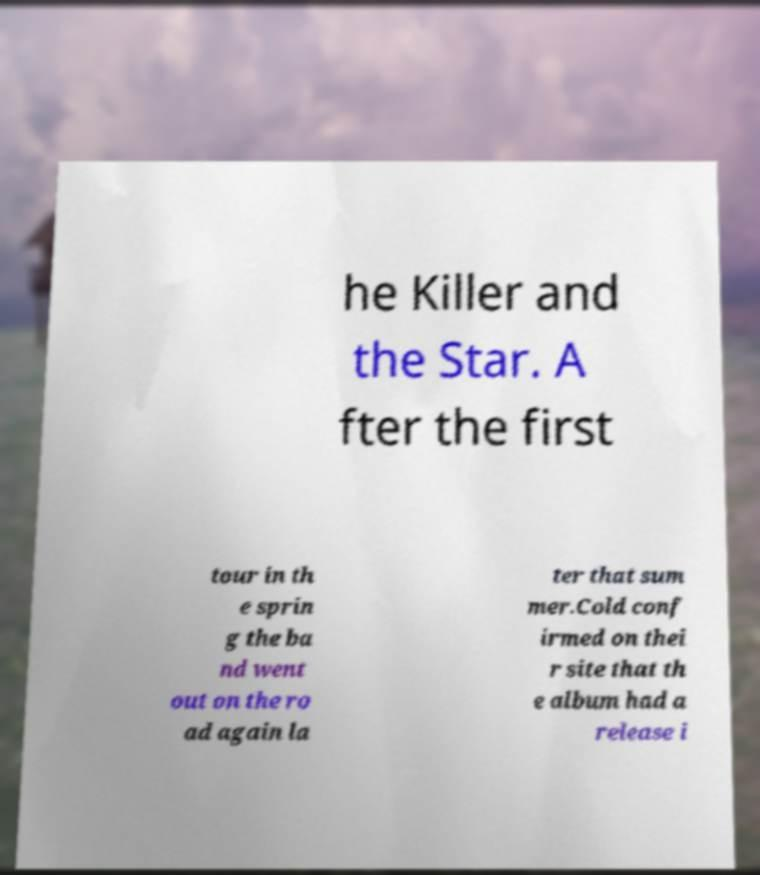I need the written content from this picture converted into text. Can you do that? he Killer and the Star. A fter the first tour in th e sprin g the ba nd went out on the ro ad again la ter that sum mer.Cold conf irmed on thei r site that th e album had a release i 